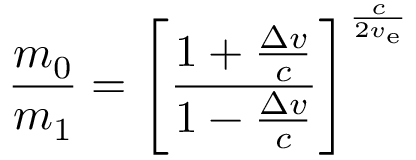Convert formula to latex. <formula><loc_0><loc_0><loc_500><loc_500>{ \frac { m _ { 0 } } { m _ { 1 } } } = \left [ { \frac { 1 + { \frac { \Delta v } { c } } } { 1 - { \frac { \Delta v } { c } } } } \right ] ^ { \frac { c } { 2 v _ { e } } }</formula> 